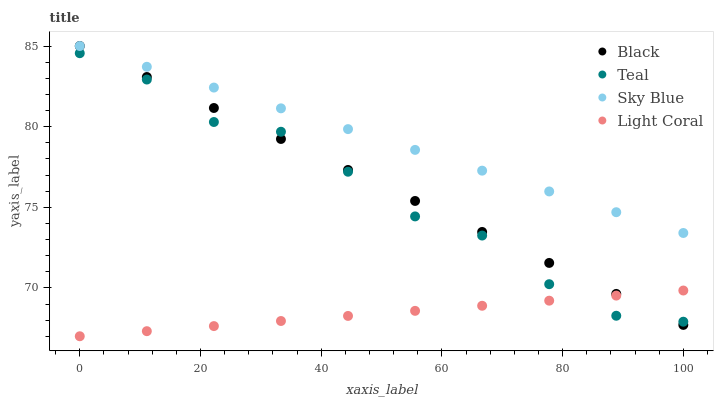Does Light Coral have the minimum area under the curve?
Answer yes or no. Yes. Does Sky Blue have the maximum area under the curve?
Answer yes or no. Yes. Does Black have the minimum area under the curve?
Answer yes or no. No. Does Black have the maximum area under the curve?
Answer yes or no. No. Is Light Coral the smoothest?
Answer yes or no. Yes. Is Teal the roughest?
Answer yes or no. Yes. Is Sky Blue the smoothest?
Answer yes or no. No. Is Sky Blue the roughest?
Answer yes or no. No. Does Light Coral have the lowest value?
Answer yes or no. Yes. Does Black have the lowest value?
Answer yes or no. No. Does Black have the highest value?
Answer yes or no. Yes. Does Teal have the highest value?
Answer yes or no. No. Is Teal less than Sky Blue?
Answer yes or no. Yes. Is Sky Blue greater than Teal?
Answer yes or no. Yes. Does Light Coral intersect Black?
Answer yes or no. Yes. Is Light Coral less than Black?
Answer yes or no. No. Is Light Coral greater than Black?
Answer yes or no. No. Does Teal intersect Sky Blue?
Answer yes or no. No. 